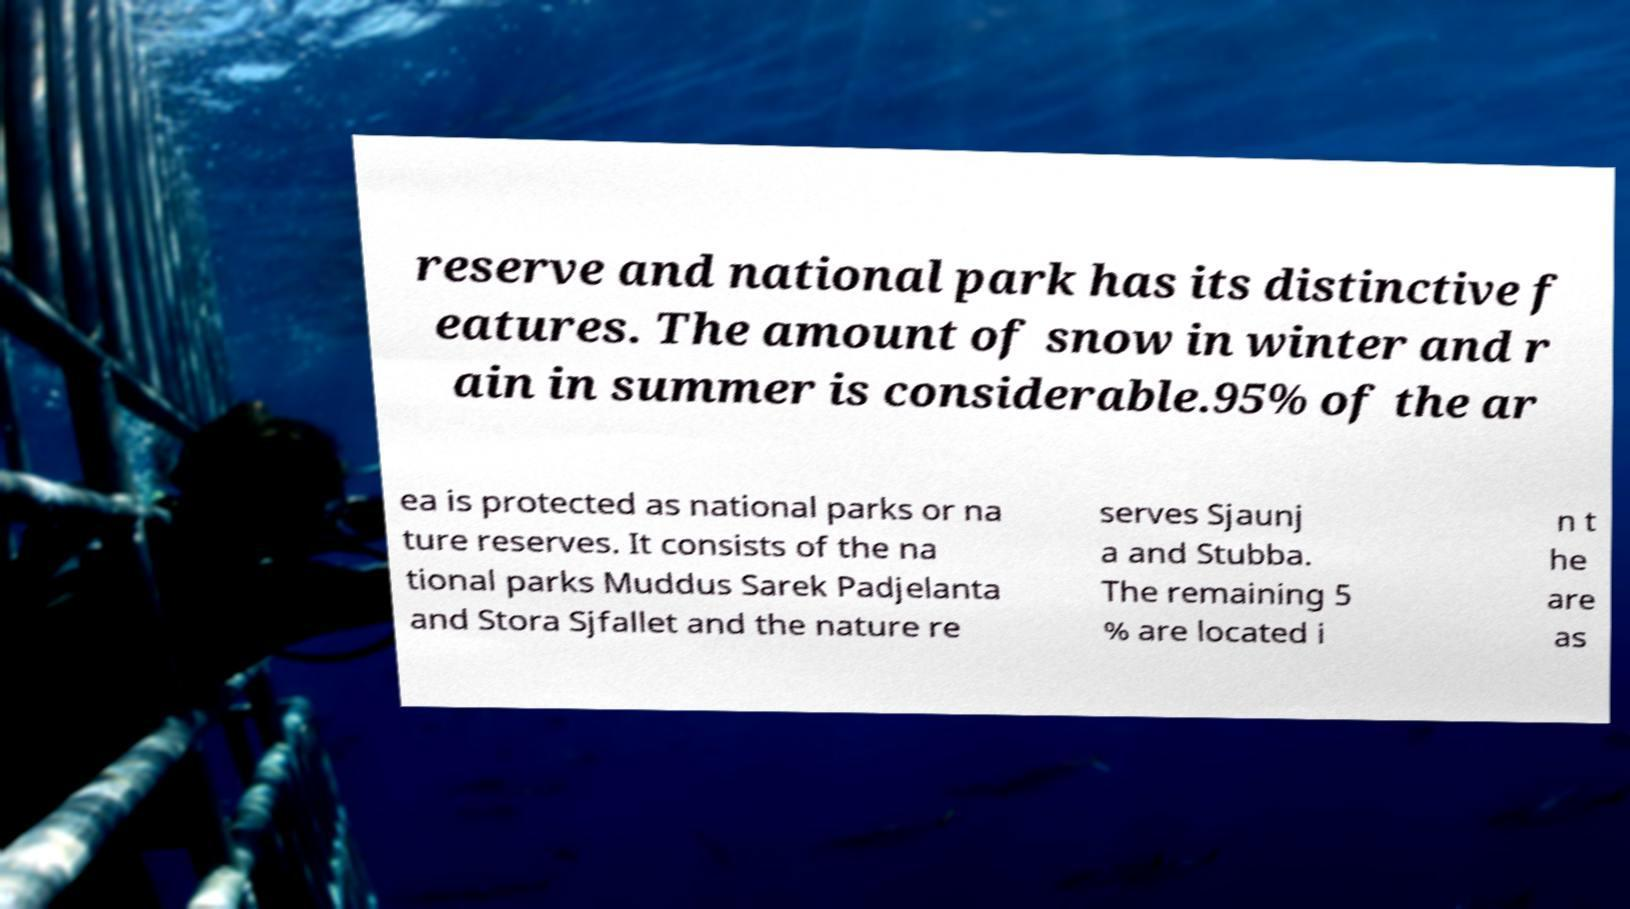For documentation purposes, I need the text within this image transcribed. Could you provide that? reserve and national park has its distinctive f eatures. The amount of snow in winter and r ain in summer is considerable.95% of the ar ea is protected as national parks or na ture reserves. It consists of the na tional parks Muddus Sarek Padjelanta and Stora Sjfallet and the nature re serves Sjaunj a and Stubba. The remaining 5 % are located i n t he are as 